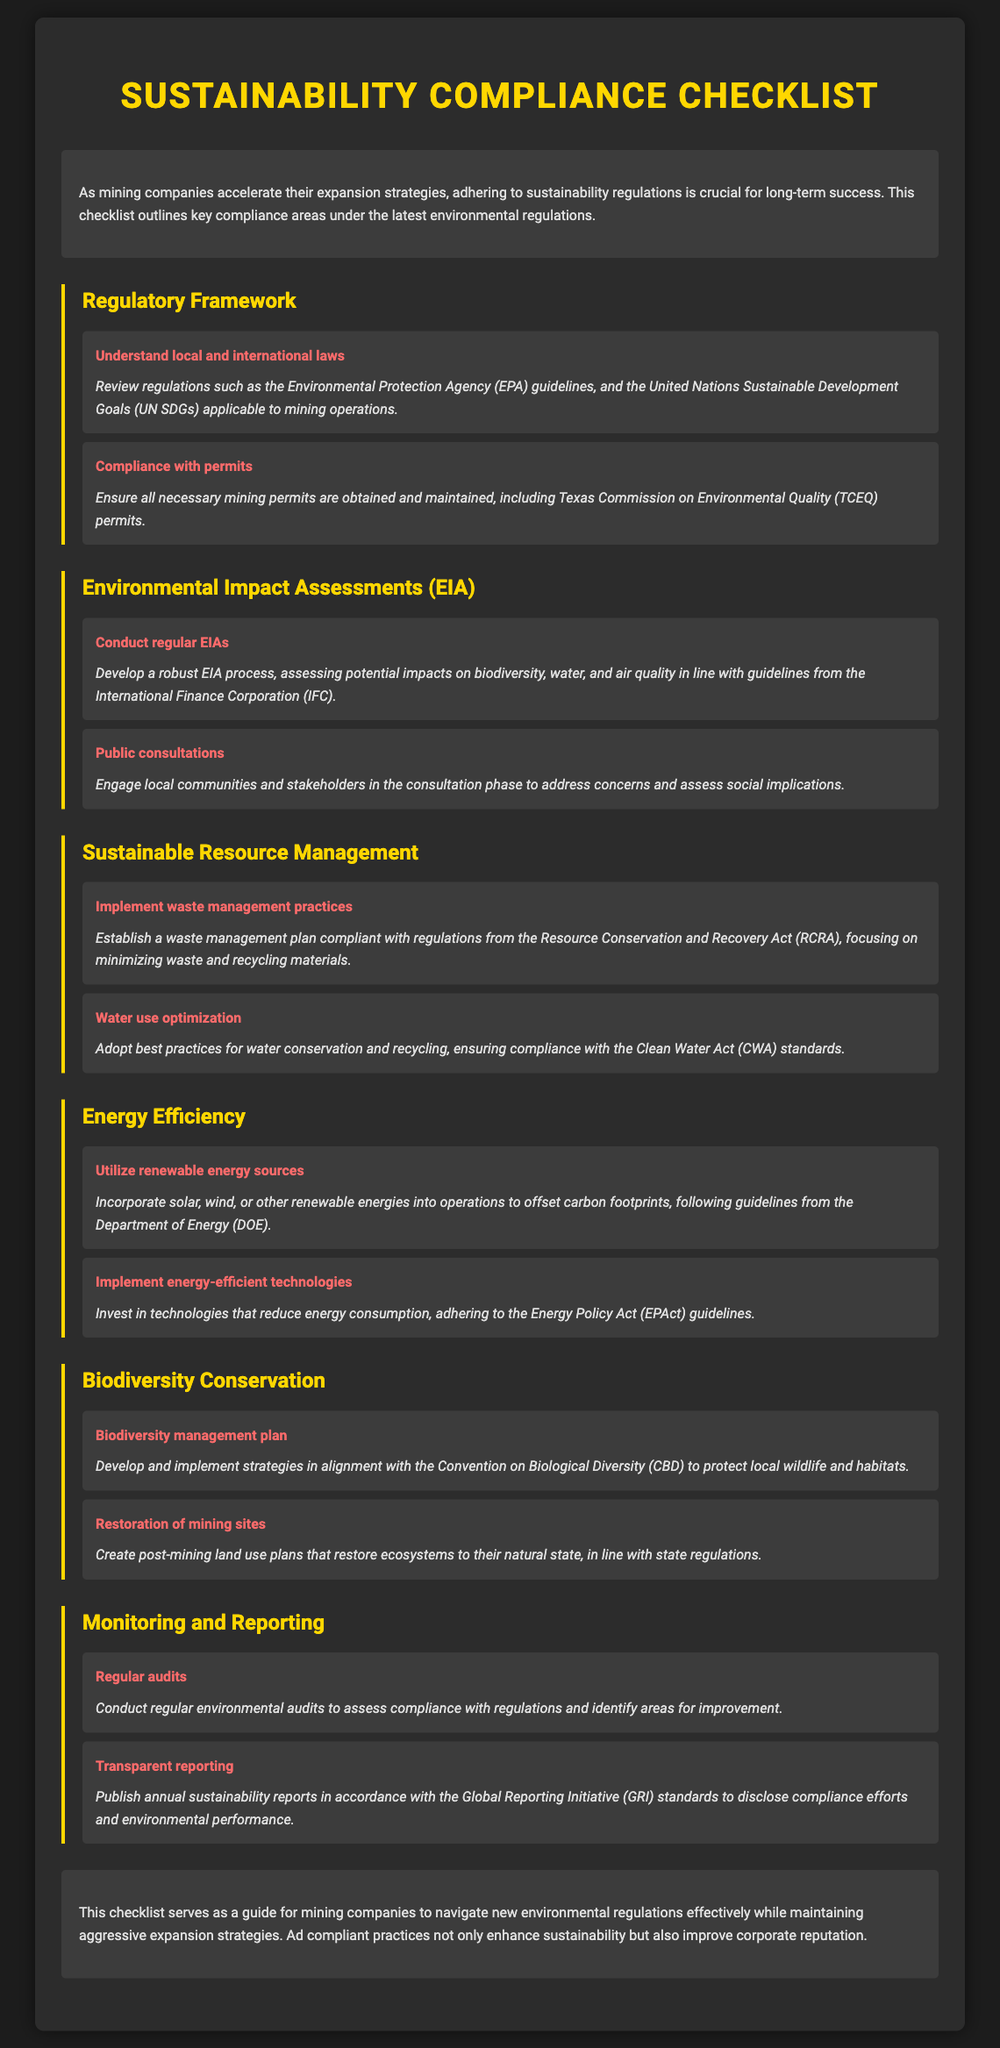what is the title of the document? The title is located at the top of the document.
Answer: Sustainability Compliance Checklist what is the main purpose of this checklist? The main purpose is stated in the introduction section of the document.
Answer: Adhering to sustainability regulations which organization’s regulations are referred to regarding waste management? The organization is mentioned in the Sustainable Resource Management section.
Answer: Resource Conservation and Recovery Act how often should Environmental Impact Assessments be conducted? Frequency is implied in the requirements under the EIA section.
Answer: Regularly what energy efficiency guideline is mentioned in the document? The guideline is provided in the Energy Efficiency section.
Answer: Energy Policy Act which strategy is suggested for Biodiversity Conservation? The strategy is listed in the Biodiversity Conservation section.
Answer: Biodiversity management plan what kind of reports should be published annually? The type of report is mentioned in the Monitoring and Reporting section.
Answer: Sustainability reports what is emphasized in the conclusion of the document? The conclusion summarizes the main focus areas discussed in the document.
Answer: Enhance sustainability who should be engaged in public consultations? The document specifies the involved parties in the EIA section.
Answer: Local communities and stakeholders 